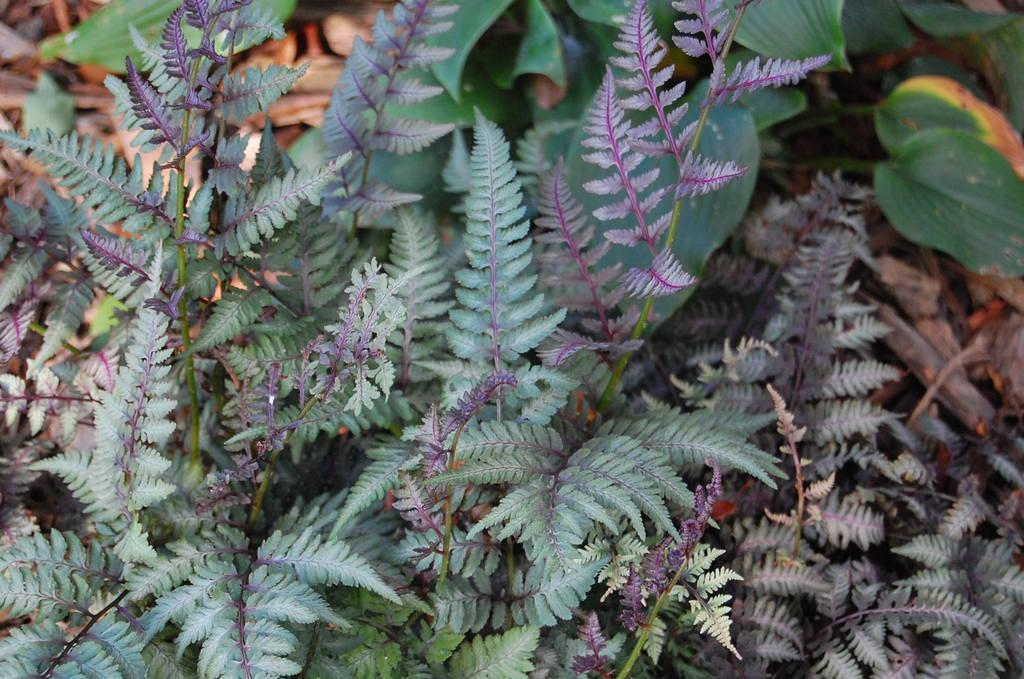What type of living organisms are present in the image? There are plants in the image. What structural components can be observed in the plants? The plants have stems and leaves. What type of trousers are the plants wearing in the image? Plants do not wear trousers, as they are living organisms and not human beings. 